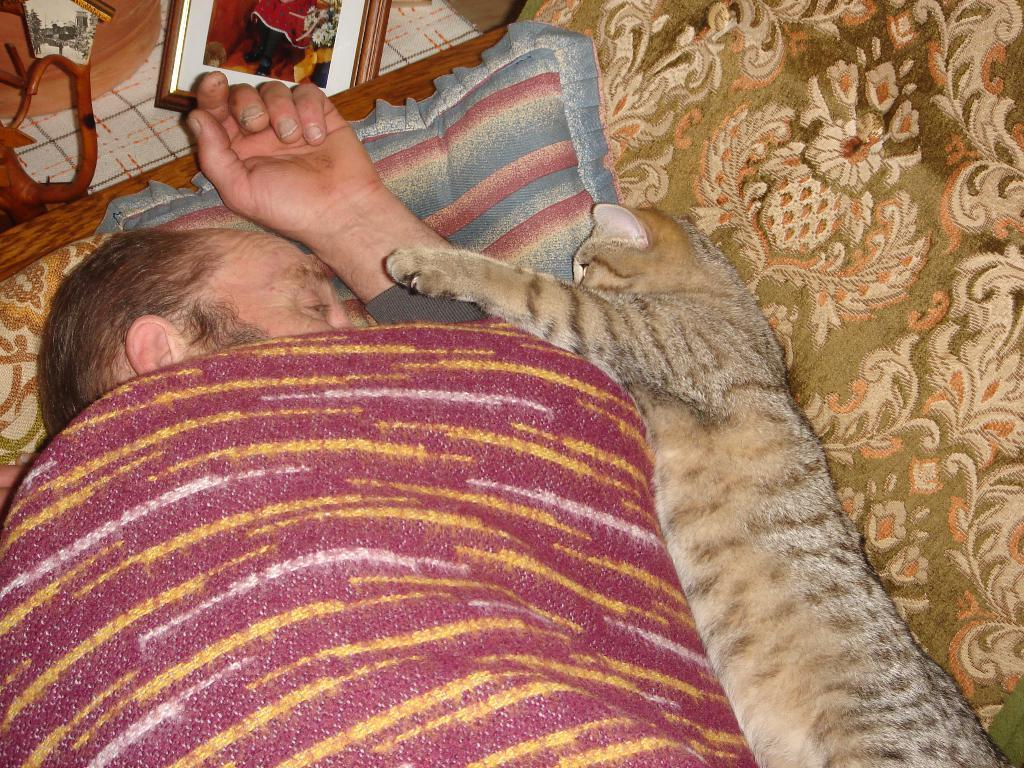What is the person in the image doing? The person is sleeping on a bed. What is supporting the person's head while they sleep? The person has a pillow under them. How is the person covered while they sleep? The person is covered by a blanket. Is there any other living creature in the image? Yes, there is a cat sleeping beside the person. What object is present near the person? There is a photo frame present near the person. What type of star can be seen in the photo frame in the image? There is no star visible in the image, and the contents of the photo frame are not described in the provided facts. 